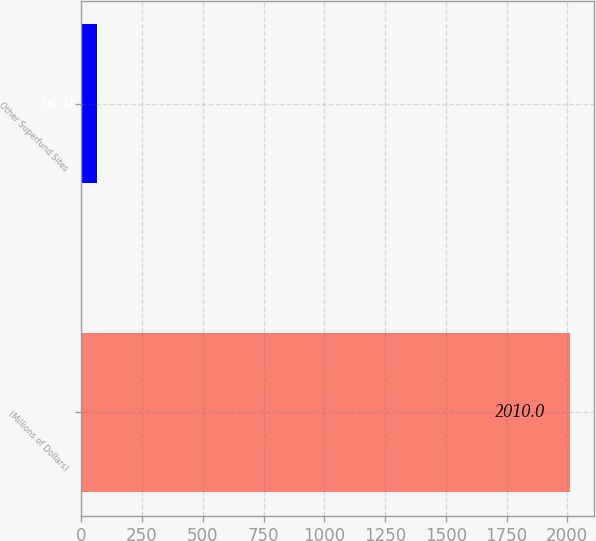Convert chart to OTSL. <chart><loc_0><loc_0><loc_500><loc_500><bar_chart><fcel>(Millions of Dollars)<fcel>Other Superfund Sites<nl><fcel>2010<fcel>66<nl></chart> 